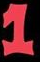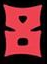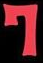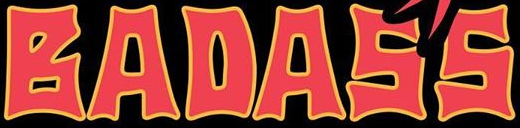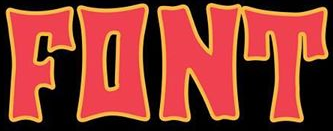What words are shown in these images in order, separated by a semicolon? 1; 8; 7; BADASS; FONT 